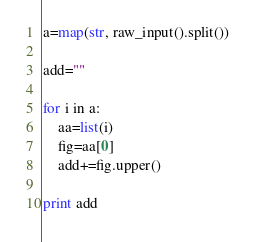Convert code to text. <code><loc_0><loc_0><loc_500><loc_500><_Python_>a=map(str, raw_input().split())

add=""

for i in a:
	aa=list(i)
	fig=aa[0]
	add+=fig.upper()

print add</code> 